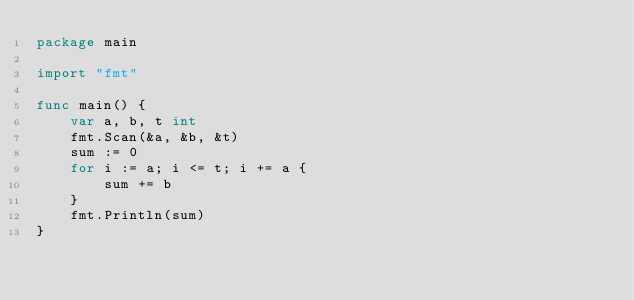<code> <loc_0><loc_0><loc_500><loc_500><_Go_>package main

import "fmt"

func main() {
	var a, b, t int
	fmt.Scan(&a, &b, &t)
	sum := 0
	for i := a; i <= t; i += a {
		sum += b
	}
	fmt.Println(sum)
}</code> 